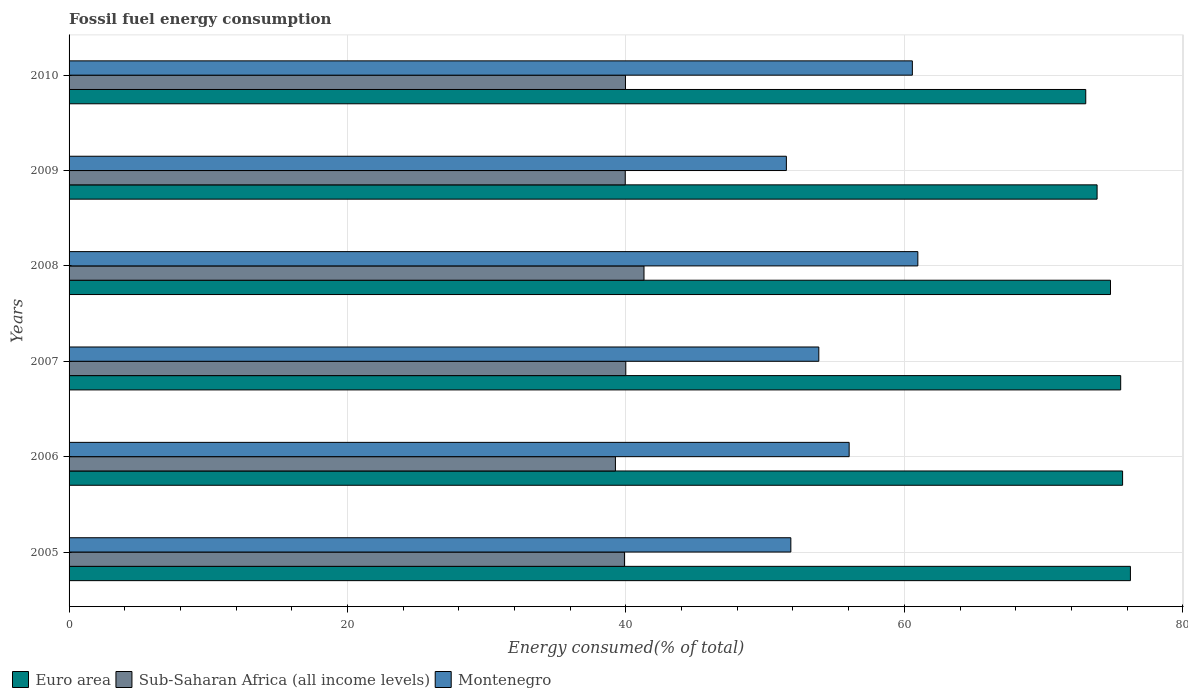How many groups of bars are there?
Provide a short and direct response. 6. What is the label of the 6th group of bars from the top?
Your answer should be very brief. 2005. In how many cases, is the number of bars for a given year not equal to the number of legend labels?
Offer a terse response. 0. What is the percentage of energy consumed in Montenegro in 2008?
Ensure brevity in your answer.  60.97. Across all years, what is the maximum percentage of energy consumed in Montenegro?
Provide a succinct answer. 60.97. Across all years, what is the minimum percentage of energy consumed in Euro area?
Ensure brevity in your answer.  73.03. In which year was the percentage of energy consumed in Sub-Saharan Africa (all income levels) maximum?
Ensure brevity in your answer.  2008. What is the total percentage of energy consumed in Sub-Saharan Africa (all income levels) in the graph?
Provide a short and direct response. 240.35. What is the difference between the percentage of energy consumed in Montenegro in 2006 and that in 2009?
Your answer should be compact. 4.51. What is the difference between the percentage of energy consumed in Sub-Saharan Africa (all income levels) in 2009 and the percentage of energy consumed in Euro area in 2007?
Make the answer very short. -35.59. What is the average percentage of energy consumed in Euro area per year?
Provide a short and direct response. 74.86. In the year 2007, what is the difference between the percentage of energy consumed in Euro area and percentage of energy consumed in Montenegro?
Your response must be concise. 21.68. In how many years, is the percentage of energy consumed in Euro area greater than 44 %?
Your answer should be very brief. 6. What is the ratio of the percentage of energy consumed in Euro area in 2005 to that in 2008?
Provide a short and direct response. 1.02. Is the percentage of energy consumed in Euro area in 2007 less than that in 2010?
Offer a very short reply. No. What is the difference between the highest and the second highest percentage of energy consumed in Montenegro?
Make the answer very short. 0.39. What is the difference between the highest and the lowest percentage of energy consumed in Montenegro?
Offer a very short reply. 9.44. In how many years, is the percentage of energy consumed in Montenegro greater than the average percentage of energy consumed in Montenegro taken over all years?
Make the answer very short. 3. Is the sum of the percentage of energy consumed in Montenegro in 2007 and 2009 greater than the maximum percentage of energy consumed in Sub-Saharan Africa (all income levels) across all years?
Ensure brevity in your answer.  Yes. What does the 2nd bar from the top in 2007 represents?
Provide a succinct answer. Sub-Saharan Africa (all income levels). What does the 1st bar from the bottom in 2009 represents?
Your answer should be compact. Euro area. Are all the bars in the graph horizontal?
Your answer should be compact. Yes. What is the difference between two consecutive major ticks on the X-axis?
Make the answer very short. 20. Are the values on the major ticks of X-axis written in scientific E-notation?
Your response must be concise. No. Does the graph contain any zero values?
Keep it short and to the point. No. Does the graph contain grids?
Ensure brevity in your answer.  Yes. Where does the legend appear in the graph?
Ensure brevity in your answer.  Bottom left. How are the legend labels stacked?
Your answer should be very brief. Horizontal. What is the title of the graph?
Your answer should be compact. Fossil fuel energy consumption. Does "Ethiopia" appear as one of the legend labels in the graph?
Provide a short and direct response. No. What is the label or title of the X-axis?
Ensure brevity in your answer.  Energy consumed(% of total). What is the label or title of the Y-axis?
Make the answer very short. Years. What is the Energy consumed(% of total) in Euro area in 2005?
Provide a short and direct response. 76.24. What is the Energy consumed(% of total) of Sub-Saharan Africa (all income levels) in 2005?
Give a very brief answer. 39.89. What is the Energy consumed(% of total) of Montenegro in 2005?
Make the answer very short. 51.85. What is the Energy consumed(% of total) of Euro area in 2006?
Offer a very short reply. 75.68. What is the Energy consumed(% of total) in Sub-Saharan Africa (all income levels) in 2006?
Provide a succinct answer. 39.25. What is the Energy consumed(% of total) in Montenegro in 2006?
Ensure brevity in your answer.  56.03. What is the Energy consumed(% of total) of Euro area in 2007?
Offer a terse response. 75.54. What is the Energy consumed(% of total) of Sub-Saharan Africa (all income levels) in 2007?
Your answer should be very brief. 39.99. What is the Energy consumed(% of total) of Montenegro in 2007?
Provide a succinct answer. 53.86. What is the Energy consumed(% of total) in Euro area in 2008?
Offer a very short reply. 74.81. What is the Energy consumed(% of total) in Sub-Saharan Africa (all income levels) in 2008?
Your response must be concise. 41.3. What is the Energy consumed(% of total) of Montenegro in 2008?
Your response must be concise. 60.97. What is the Energy consumed(% of total) in Euro area in 2009?
Provide a succinct answer. 73.85. What is the Energy consumed(% of total) in Sub-Saharan Africa (all income levels) in 2009?
Provide a succinct answer. 39.95. What is the Energy consumed(% of total) of Montenegro in 2009?
Your answer should be compact. 51.53. What is the Energy consumed(% of total) in Euro area in 2010?
Keep it short and to the point. 73.03. What is the Energy consumed(% of total) of Sub-Saharan Africa (all income levels) in 2010?
Your answer should be compact. 39.97. What is the Energy consumed(% of total) of Montenegro in 2010?
Keep it short and to the point. 60.58. Across all years, what is the maximum Energy consumed(% of total) of Euro area?
Give a very brief answer. 76.24. Across all years, what is the maximum Energy consumed(% of total) in Sub-Saharan Africa (all income levels)?
Offer a very short reply. 41.3. Across all years, what is the maximum Energy consumed(% of total) in Montenegro?
Give a very brief answer. 60.97. Across all years, what is the minimum Energy consumed(% of total) in Euro area?
Offer a very short reply. 73.03. Across all years, what is the minimum Energy consumed(% of total) of Sub-Saharan Africa (all income levels)?
Make the answer very short. 39.25. Across all years, what is the minimum Energy consumed(% of total) of Montenegro?
Provide a short and direct response. 51.53. What is the total Energy consumed(% of total) of Euro area in the graph?
Provide a short and direct response. 449.14. What is the total Energy consumed(% of total) of Sub-Saharan Africa (all income levels) in the graph?
Your response must be concise. 240.35. What is the total Energy consumed(% of total) of Montenegro in the graph?
Offer a terse response. 334.81. What is the difference between the Energy consumed(% of total) in Euro area in 2005 and that in 2006?
Your answer should be very brief. 0.56. What is the difference between the Energy consumed(% of total) of Sub-Saharan Africa (all income levels) in 2005 and that in 2006?
Offer a terse response. 0.65. What is the difference between the Energy consumed(% of total) in Montenegro in 2005 and that in 2006?
Make the answer very short. -4.19. What is the difference between the Energy consumed(% of total) in Euro area in 2005 and that in 2007?
Your answer should be very brief. 0.7. What is the difference between the Energy consumed(% of total) of Sub-Saharan Africa (all income levels) in 2005 and that in 2007?
Make the answer very short. -0.1. What is the difference between the Energy consumed(% of total) of Montenegro in 2005 and that in 2007?
Your answer should be very brief. -2.01. What is the difference between the Energy consumed(% of total) of Euro area in 2005 and that in 2008?
Your response must be concise. 1.43. What is the difference between the Energy consumed(% of total) in Sub-Saharan Africa (all income levels) in 2005 and that in 2008?
Make the answer very short. -1.4. What is the difference between the Energy consumed(% of total) of Montenegro in 2005 and that in 2008?
Your answer should be very brief. -9.12. What is the difference between the Energy consumed(% of total) of Euro area in 2005 and that in 2009?
Provide a succinct answer. 2.39. What is the difference between the Energy consumed(% of total) of Sub-Saharan Africa (all income levels) in 2005 and that in 2009?
Make the answer very short. -0.06. What is the difference between the Energy consumed(% of total) of Montenegro in 2005 and that in 2009?
Your response must be concise. 0.32. What is the difference between the Energy consumed(% of total) in Euro area in 2005 and that in 2010?
Make the answer very short. 3.21. What is the difference between the Energy consumed(% of total) in Sub-Saharan Africa (all income levels) in 2005 and that in 2010?
Make the answer very short. -0.07. What is the difference between the Energy consumed(% of total) of Montenegro in 2005 and that in 2010?
Keep it short and to the point. -8.73. What is the difference between the Energy consumed(% of total) of Euro area in 2006 and that in 2007?
Your answer should be very brief. 0.14. What is the difference between the Energy consumed(% of total) of Sub-Saharan Africa (all income levels) in 2006 and that in 2007?
Ensure brevity in your answer.  -0.75. What is the difference between the Energy consumed(% of total) of Montenegro in 2006 and that in 2007?
Provide a short and direct response. 2.18. What is the difference between the Energy consumed(% of total) in Euro area in 2006 and that in 2008?
Make the answer very short. 0.87. What is the difference between the Energy consumed(% of total) in Sub-Saharan Africa (all income levels) in 2006 and that in 2008?
Offer a very short reply. -2.05. What is the difference between the Energy consumed(% of total) in Montenegro in 2006 and that in 2008?
Provide a succinct answer. -4.93. What is the difference between the Energy consumed(% of total) of Euro area in 2006 and that in 2009?
Make the answer very short. 1.83. What is the difference between the Energy consumed(% of total) in Sub-Saharan Africa (all income levels) in 2006 and that in 2009?
Keep it short and to the point. -0.71. What is the difference between the Energy consumed(% of total) in Montenegro in 2006 and that in 2009?
Ensure brevity in your answer.  4.51. What is the difference between the Energy consumed(% of total) in Euro area in 2006 and that in 2010?
Provide a short and direct response. 2.65. What is the difference between the Energy consumed(% of total) of Sub-Saharan Africa (all income levels) in 2006 and that in 2010?
Ensure brevity in your answer.  -0.72. What is the difference between the Energy consumed(% of total) of Montenegro in 2006 and that in 2010?
Offer a very short reply. -4.54. What is the difference between the Energy consumed(% of total) of Euro area in 2007 and that in 2008?
Provide a succinct answer. 0.73. What is the difference between the Energy consumed(% of total) of Sub-Saharan Africa (all income levels) in 2007 and that in 2008?
Your answer should be compact. -1.31. What is the difference between the Energy consumed(% of total) in Montenegro in 2007 and that in 2008?
Your answer should be very brief. -7.11. What is the difference between the Energy consumed(% of total) in Euro area in 2007 and that in 2009?
Ensure brevity in your answer.  1.69. What is the difference between the Energy consumed(% of total) of Sub-Saharan Africa (all income levels) in 2007 and that in 2009?
Your answer should be compact. 0.04. What is the difference between the Energy consumed(% of total) in Montenegro in 2007 and that in 2009?
Give a very brief answer. 2.33. What is the difference between the Energy consumed(% of total) in Euro area in 2007 and that in 2010?
Make the answer very short. 2.51. What is the difference between the Energy consumed(% of total) in Sub-Saharan Africa (all income levels) in 2007 and that in 2010?
Offer a very short reply. 0.02. What is the difference between the Energy consumed(% of total) of Montenegro in 2007 and that in 2010?
Keep it short and to the point. -6.72. What is the difference between the Energy consumed(% of total) in Euro area in 2008 and that in 2009?
Provide a short and direct response. 0.96. What is the difference between the Energy consumed(% of total) of Sub-Saharan Africa (all income levels) in 2008 and that in 2009?
Provide a short and direct response. 1.35. What is the difference between the Energy consumed(% of total) of Montenegro in 2008 and that in 2009?
Make the answer very short. 9.44. What is the difference between the Energy consumed(% of total) of Euro area in 2008 and that in 2010?
Your answer should be very brief. 1.78. What is the difference between the Energy consumed(% of total) of Sub-Saharan Africa (all income levels) in 2008 and that in 2010?
Keep it short and to the point. 1.33. What is the difference between the Energy consumed(% of total) of Montenegro in 2008 and that in 2010?
Keep it short and to the point. 0.39. What is the difference between the Energy consumed(% of total) in Euro area in 2009 and that in 2010?
Keep it short and to the point. 0.81. What is the difference between the Energy consumed(% of total) of Sub-Saharan Africa (all income levels) in 2009 and that in 2010?
Your answer should be very brief. -0.02. What is the difference between the Energy consumed(% of total) in Montenegro in 2009 and that in 2010?
Your answer should be very brief. -9.05. What is the difference between the Energy consumed(% of total) of Euro area in 2005 and the Energy consumed(% of total) of Sub-Saharan Africa (all income levels) in 2006?
Keep it short and to the point. 36.99. What is the difference between the Energy consumed(% of total) of Euro area in 2005 and the Energy consumed(% of total) of Montenegro in 2006?
Provide a short and direct response. 20.2. What is the difference between the Energy consumed(% of total) in Sub-Saharan Africa (all income levels) in 2005 and the Energy consumed(% of total) in Montenegro in 2006?
Provide a short and direct response. -16.14. What is the difference between the Energy consumed(% of total) in Euro area in 2005 and the Energy consumed(% of total) in Sub-Saharan Africa (all income levels) in 2007?
Keep it short and to the point. 36.25. What is the difference between the Energy consumed(% of total) of Euro area in 2005 and the Energy consumed(% of total) of Montenegro in 2007?
Keep it short and to the point. 22.38. What is the difference between the Energy consumed(% of total) in Sub-Saharan Africa (all income levels) in 2005 and the Energy consumed(% of total) in Montenegro in 2007?
Offer a terse response. -13.96. What is the difference between the Energy consumed(% of total) of Euro area in 2005 and the Energy consumed(% of total) of Sub-Saharan Africa (all income levels) in 2008?
Provide a succinct answer. 34.94. What is the difference between the Energy consumed(% of total) in Euro area in 2005 and the Energy consumed(% of total) in Montenegro in 2008?
Make the answer very short. 15.27. What is the difference between the Energy consumed(% of total) of Sub-Saharan Africa (all income levels) in 2005 and the Energy consumed(% of total) of Montenegro in 2008?
Give a very brief answer. -21.08. What is the difference between the Energy consumed(% of total) of Euro area in 2005 and the Energy consumed(% of total) of Sub-Saharan Africa (all income levels) in 2009?
Offer a terse response. 36.29. What is the difference between the Energy consumed(% of total) in Euro area in 2005 and the Energy consumed(% of total) in Montenegro in 2009?
Your answer should be very brief. 24.71. What is the difference between the Energy consumed(% of total) of Sub-Saharan Africa (all income levels) in 2005 and the Energy consumed(% of total) of Montenegro in 2009?
Offer a terse response. -11.63. What is the difference between the Energy consumed(% of total) of Euro area in 2005 and the Energy consumed(% of total) of Sub-Saharan Africa (all income levels) in 2010?
Provide a short and direct response. 36.27. What is the difference between the Energy consumed(% of total) of Euro area in 2005 and the Energy consumed(% of total) of Montenegro in 2010?
Offer a very short reply. 15.66. What is the difference between the Energy consumed(% of total) of Sub-Saharan Africa (all income levels) in 2005 and the Energy consumed(% of total) of Montenegro in 2010?
Offer a very short reply. -20.68. What is the difference between the Energy consumed(% of total) of Euro area in 2006 and the Energy consumed(% of total) of Sub-Saharan Africa (all income levels) in 2007?
Your response must be concise. 35.69. What is the difference between the Energy consumed(% of total) in Euro area in 2006 and the Energy consumed(% of total) in Montenegro in 2007?
Ensure brevity in your answer.  21.82. What is the difference between the Energy consumed(% of total) in Sub-Saharan Africa (all income levels) in 2006 and the Energy consumed(% of total) in Montenegro in 2007?
Keep it short and to the point. -14.61. What is the difference between the Energy consumed(% of total) in Euro area in 2006 and the Energy consumed(% of total) in Sub-Saharan Africa (all income levels) in 2008?
Your response must be concise. 34.38. What is the difference between the Energy consumed(% of total) of Euro area in 2006 and the Energy consumed(% of total) of Montenegro in 2008?
Offer a terse response. 14.71. What is the difference between the Energy consumed(% of total) of Sub-Saharan Africa (all income levels) in 2006 and the Energy consumed(% of total) of Montenegro in 2008?
Offer a terse response. -21.72. What is the difference between the Energy consumed(% of total) in Euro area in 2006 and the Energy consumed(% of total) in Sub-Saharan Africa (all income levels) in 2009?
Make the answer very short. 35.73. What is the difference between the Energy consumed(% of total) in Euro area in 2006 and the Energy consumed(% of total) in Montenegro in 2009?
Offer a terse response. 24.15. What is the difference between the Energy consumed(% of total) in Sub-Saharan Africa (all income levels) in 2006 and the Energy consumed(% of total) in Montenegro in 2009?
Your response must be concise. -12.28. What is the difference between the Energy consumed(% of total) of Euro area in 2006 and the Energy consumed(% of total) of Sub-Saharan Africa (all income levels) in 2010?
Provide a short and direct response. 35.71. What is the difference between the Energy consumed(% of total) of Euro area in 2006 and the Energy consumed(% of total) of Montenegro in 2010?
Give a very brief answer. 15.1. What is the difference between the Energy consumed(% of total) of Sub-Saharan Africa (all income levels) in 2006 and the Energy consumed(% of total) of Montenegro in 2010?
Ensure brevity in your answer.  -21.33. What is the difference between the Energy consumed(% of total) in Euro area in 2007 and the Energy consumed(% of total) in Sub-Saharan Africa (all income levels) in 2008?
Make the answer very short. 34.24. What is the difference between the Energy consumed(% of total) of Euro area in 2007 and the Energy consumed(% of total) of Montenegro in 2008?
Your response must be concise. 14.57. What is the difference between the Energy consumed(% of total) in Sub-Saharan Africa (all income levels) in 2007 and the Energy consumed(% of total) in Montenegro in 2008?
Provide a short and direct response. -20.98. What is the difference between the Energy consumed(% of total) in Euro area in 2007 and the Energy consumed(% of total) in Sub-Saharan Africa (all income levels) in 2009?
Provide a succinct answer. 35.59. What is the difference between the Energy consumed(% of total) of Euro area in 2007 and the Energy consumed(% of total) of Montenegro in 2009?
Give a very brief answer. 24.01. What is the difference between the Energy consumed(% of total) of Sub-Saharan Africa (all income levels) in 2007 and the Energy consumed(% of total) of Montenegro in 2009?
Make the answer very short. -11.53. What is the difference between the Energy consumed(% of total) in Euro area in 2007 and the Energy consumed(% of total) in Sub-Saharan Africa (all income levels) in 2010?
Offer a very short reply. 35.57. What is the difference between the Energy consumed(% of total) of Euro area in 2007 and the Energy consumed(% of total) of Montenegro in 2010?
Keep it short and to the point. 14.96. What is the difference between the Energy consumed(% of total) in Sub-Saharan Africa (all income levels) in 2007 and the Energy consumed(% of total) in Montenegro in 2010?
Ensure brevity in your answer.  -20.58. What is the difference between the Energy consumed(% of total) of Euro area in 2008 and the Energy consumed(% of total) of Sub-Saharan Africa (all income levels) in 2009?
Your answer should be very brief. 34.86. What is the difference between the Energy consumed(% of total) of Euro area in 2008 and the Energy consumed(% of total) of Montenegro in 2009?
Give a very brief answer. 23.28. What is the difference between the Energy consumed(% of total) in Sub-Saharan Africa (all income levels) in 2008 and the Energy consumed(% of total) in Montenegro in 2009?
Your answer should be very brief. -10.23. What is the difference between the Energy consumed(% of total) of Euro area in 2008 and the Energy consumed(% of total) of Sub-Saharan Africa (all income levels) in 2010?
Provide a short and direct response. 34.84. What is the difference between the Energy consumed(% of total) in Euro area in 2008 and the Energy consumed(% of total) in Montenegro in 2010?
Your answer should be compact. 14.23. What is the difference between the Energy consumed(% of total) in Sub-Saharan Africa (all income levels) in 2008 and the Energy consumed(% of total) in Montenegro in 2010?
Your response must be concise. -19.28. What is the difference between the Energy consumed(% of total) of Euro area in 2009 and the Energy consumed(% of total) of Sub-Saharan Africa (all income levels) in 2010?
Offer a very short reply. 33.88. What is the difference between the Energy consumed(% of total) of Euro area in 2009 and the Energy consumed(% of total) of Montenegro in 2010?
Provide a succinct answer. 13.27. What is the difference between the Energy consumed(% of total) in Sub-Saharan Africa (all income levels) in 2009 and the Energy consumed(% of total) in Montenegro in 2010?
Offer a very short reply. -20.62. What is the average Energy consumed(% of total) of Euro area per year?
Keep it short and to the point. 74.86. What is the average Energy consumed(% of total) in Sub-Saharan Africa (all income levels) per year?
Keep it short and to the point. 40.06. What is the average Energy consumed(% of total) of Montenegro per year?
Make the answer very short. 55.8. In the year 2005, what is the difference between the Energy consumed(% of total) in Euro area and Energy consumed(% of total) in Sub-Saharan Africa (all income levels)?
Make the answer very short. 36.34. In the year 2005, what is the difference between the Energy consumed(% of total) in Euro area and Energy consumed(% of total) in Montenegro?
Give a very brief answer. 24.39. In the year 2005, what is the difference between the Energy consumed(% of total) in Sub-Saharan Africa (all income levels) and Energy consumed(% of total) in Montenegro?
Your answer should be compact. -11.95. In the year 2006, what is the difference between the Energy consumed(% of total) of Euro area and Energy consumed(% of total) of Sub-Saharan Africa (all income levels)?
Your answer should be compact. 36.43. In the year 2006, what is the difference between the Energy consumed(% of total) in Euro area and Energy consumed(% of total) in Montenegro?
Your answer should be compact. 19.64. In the year 2006, what is the difference between the Energy consumed(% of total) of Sub-Saharan Africa (all income levels) and Energy consumed(% of total) of Montenegro?
Offer a very short reply. -16.79. In the year 2007, what is the difference between the Energy consumed(% of total) in Euro area and Energy consumed(% of total) in Sub-Saharan Africa (all income levels)?
Provide a short and direct response. 35.55. In the year 2007, what is the difference between the Energy consumed(% of total) of Euro area and Energy consumed(% of total) of Montenegro?
Your response must be concise. 21.68. In the year 2007, what is the difference between the Energy consumed(% of total) in Sub-Saharan Africa (all income levels) and Energy consumed(% of total) in Montenegro?
Ensure brevity in your answer.  -13.86. In the year 2008, what is the difference between the Energy consumed(% of total) in Euro area and Energy consumed(% of total) in Sub-Saharan Africa (all income levels)?
Make the answer very short. 33.51. In the year 2008, what is the difference between the Energy consumed(% of total) of Euro area and Energy consumed(% of total) of Montenegro?
Provide a succinct answer. 13.84. In the year 2008, what is the difference between the Energy consumed(% of total) in Sub-Saharan Africa (all income levels) and Energy consumed(% of total) in Montenegro?
Give a very brief answer. -19.67. In the year 2009, what is the difference between the Energy consumed(% of total) in Euro area and Energy consumed(% of total) in Sub-Saharan Africa (all income levels)?
Provide a succinct answer. 33.89. In the year 2009, what is the difference between the Energy consumed(% of total) of Euro area and Energy consumed(% of total) of Montenegro?
Your response must be concise. 22.32. In the year 2009, what is the difference between the Energy consumed(% of total) of Sub-Saharan Africa (all income levels) and Energy consumed(% of total) of Montenegro?
Offer a very short reply. -11.57. In the year 2010, what is the difference between the Energy consumed(% of total) of Euro area and Energy consumed(% of total) of Sub-Saharan Africa (all income levels)?
Make the answer very short. 33.06. In the year 2010, what is the difference between the Energy consumed(% of total) of Euro area and Energy consumed(% of total) of Montenegro?
Provide a succinct answer. 12.46. In the year 2010, what is the difference between the Energy consumed(% of total) of Sub-Saharan Africa (all income levels) and Energy consumed(% of total) of Montenegro?
Your answer should be very brief. -20.61. What is the ratio of the Energy consumed(% of total) in Euro area in 2005 to that in 2006?
Make the answer very short. 1.01. What is the ratio of the Energy consumed(% of total) in Sub-Saharan Africa (all income levels) in 2005 to that in 2006?
Provide a short and direct response. 1.02. What is the ratio of the Energy consumed(% of total) of Montenegro in 2005 to that in 2006?
Offer a very short reply. 0.93. What is the ratio of the Energy consumed(% of total) in Euro area in 2005 to that in 2007?
Provide a succinct answer. 1.01. What is the ratio of the Energy consumed(% of total) of Sub-Saharan Africa (all income levels) in 2005 to that in 2007?
Provide a short and direct response. 1. What is the ratio of the Energy consumed(% of total) in Montenegro in 2005 to that in 2007?
Keep it short and to the point. 0.96. What is the ratio of the Energy consumed(% of total) of Euro area in 2005 to that in 2008?
Offer a terse response. 1.02. What is the ratio of the Energy consumed(% of total) in Montenegro in 2005 to that in 2008?
Your answer should be compact. 0.85. What is the ratio of the Energy consumed(% of total) in Euro area in 2005 to that in 2009?
Keep it short and to the point. 1.03. What is the ratio of the Energy consumed(% of total) in Sub-Saharan Africa (all income levels) in 2005 to that in 2009?
Give a very brief answer. 1. What is the ratio of the Energy consumed(% of total) in Euro area in 2005 to that in 2010?
Provide a succinct answer. 1.04. What is the ratio of the Energy consumed(% of total) of Sub-Saharan Africa (all income levels) in 2005 to that in 2010?
Your answer should be very brief. 1. What is the ratio of the Energy consumed(% of total) of Montenegro in 2005 to that in 2010?
Offer a very short reply. 0.86. What is the ratio of the Energy consumed(% of total) in Sub-Saharan Africa (all income levels) in 2006 to that in 2007?
Give a very brief answer. 0.98. What is the ratio of the Energy consumed(% of total) of Montenegro in 2006 to that in 2007?
Your answer should be compact. 1.04. What is the ratio of the Energy consumed(% of total) in Euro area in 2006 to that in 2008?
Your answer should be compact. 1.01. What is the ratio of the Energy consumed(% of total) in Sub-Saharan Africa (all income levels) in 2006 to that in 2008?
Keep it short and to the point. 0.95. What is the ratio of the Energy consumed(% of total) of Montenegro in 2006 to that in 2008?
Offer a terse response. 0.92. What is the ratio of the Energy consumed(% of total) in Euro area in 2006 to that in 2009?
Give a very brief answer. 1.02. What is the ratio of the Energy consumed(% of total) in Sub-Saharan Africa (all income levels) in 2006 to that in 2009?
Keep it short and to the point. 0.98. What is the ratio of the Energy consumed(% of total) of Montenegro in 2006 to that in 2009?
Offer a terse response. 1.09. What is the ratio of the Energy consumed(% of total) in Euro area in 2006 to that in 2010?
Provide a succinct answer. 1.04. What is the ratio of the Energy consumed(% of total) in Sub-Saharan Africa (all income levels) in 2006 to that in 2010?
Provide a short and direct response. 0.98. What is the ratio of the Energy consumed(% of total) of Montenegro in 2006 to that in 2010?
Your answer should be very brief. 0.93. What is the ratio of the Energy consumed(% of total) of Euro area in 2007 to that in 2008?
Ensure brevity in your answer.  1.01. What is the ratio of the Energy consumed(% of total) in Sub-Saharan Africa (all income levels) in 2007 to that in 2008?
Your response must be concise. 0.97. What is the ratio of the Energy consumed(% of total) in Montenegro in 2007 to that in 2008?
Offer a terse response. 0.88. What is the ratio of the Energy consumed(% of total) in Euro area in 2007 to that in 2009?
Provide a short and direct response. 1.02. What is the ratio of the Energy consumed(% of total) of Sub-Saharan Africa (all income levels) in 2007 to that in 2009?
Offer a very short reply. 1. What is the ratio of the Energy consumed(% of total) in Montenegro in 2007 to that in 2009?
Make the answer very short. 1.05. What is the ratio of the Energy consumed(% of total) of Euro area in 2007 to that in 2010?
Ensure brevity in your answer.  1.03. What is the ratio of the Energy consumed(% of total) in Sub-Saharan Africa (all income levels) in 2007 to that in 2010?
Your answer should be compact. 1. What is the ratio of the Energy consumed(% of total) in Montenegro in 2007 to that in 2010?
Make the answer very short. 0.89. What is the ratio of the Energy consumed(% of total) in Sub-Saharan Africa (all income levels) in 2008 to that in 2009?
Make the answer very short. 1.03. What is the ratio of the Energy consumed(% of total) of Montenegro in 2008 to that in 2009?
Your response must be concise. 1.18. What is the ratio of the Energy consumed(% of total) in Euro area in 2008 to that in 2010?
Your response must be concise. 1.02. What is the ratio of the Energy consumed(% of total) of Sub-Saharan Africa (all income levels) in 2008 to that in 2010?
Ensure brevity in your answer.  1.03. What is the ratio of the Energy consumed(% of total) in Montenegro in 2008 to that in 2010?
Your answer should be compact. 1.01. What is the ratio of the Energy consumed(% of total) of Euro area in 2009 to that in 2010?
Ensure brevity in your answer.  1.01. What is the ratio of the Energy consumed(% of total) of Sub-Saharan Africa (all income levels) in 2009 to that in 2010?
Provide a short and direct response. 1. What is the ratio of the Energy consumed(% of total) of Montenegro in 2009 to that in 2010?
Provide a short and direct response. 0.85. What is the difference between the highest and the second highest Energy consumed(% of total) of Euro area?
Give a very brief answer. 0.56. What is the difference between the highest and the second highest Energy consumed(% of total) in Sub-Saharan Africa (all income levels)?
Your response must be concise. 1.31. What is the difference between the highest and the second highest Energy consumed(% of total) in Montenegro?
Provide a succinct answer. 0.39. What is the difference between the highest and the lowest Energy consumed(% of total) in Euro area?
Make the answer very short. 3.21. What is the difference between the highest and the lowest Energy consumed(% of total) in Sub-Saharan Africa (all income levels)?
Your response must be concise. 2.05. What is the difference between the highest and the lowest Energy consumed(% of total) in Montenegro?
Provide a succinct answer. 9.44. 